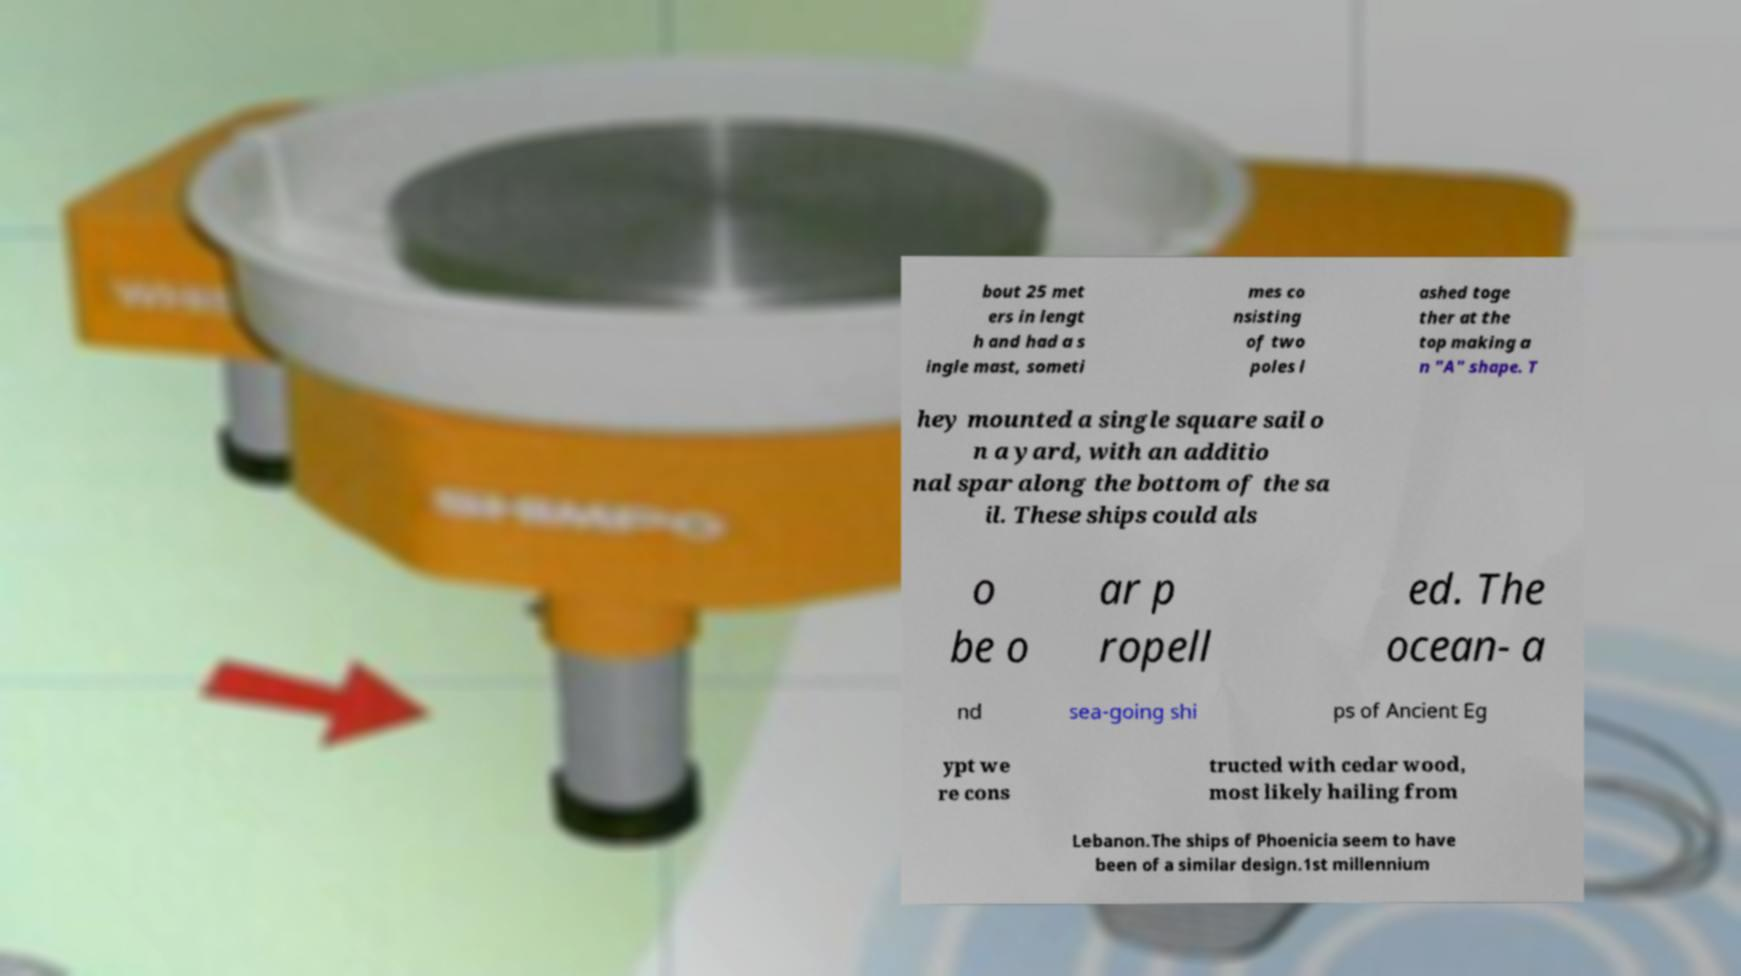Please identify and transcribe the text found in this image. bout 25 met ers in lengt h and had a s ingle mast, someti mes co nsisting of two poles l ashed toge ther at the top making a n "A" shape. T hey mounted a single square sail o n a yard, with an additio nal spar along the bottom of the sa il. These ships could als o be o ar p ropell ed. The ocean- a nd sea-going shi ps of Ancient Eg ypt we re cons tructed with cedar wood, most likely hailing from Lebanon.The ships of Phoenicia seem to have been of a similar design.1st millennium 